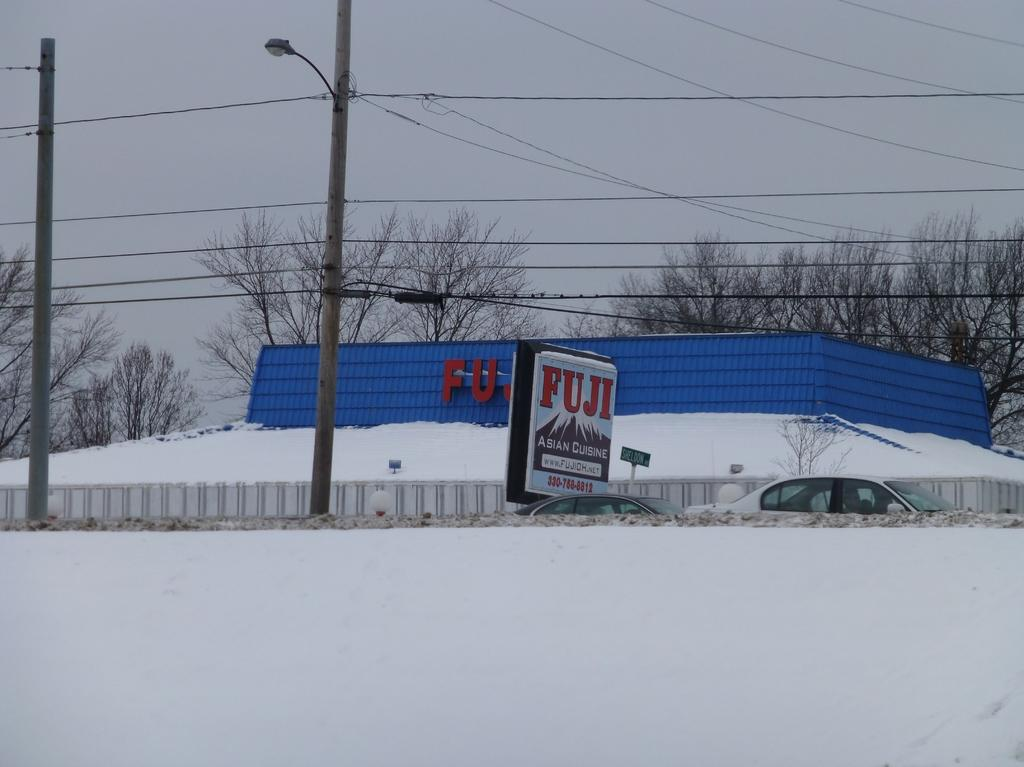<image>
Write a terse but informative summary of the picture. A blue restaurant called Fuji covered in snow 